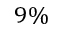Convert formula to latex. <formula><loc_0><loc_0><loc_500><loc_500>9 \%</formula> 